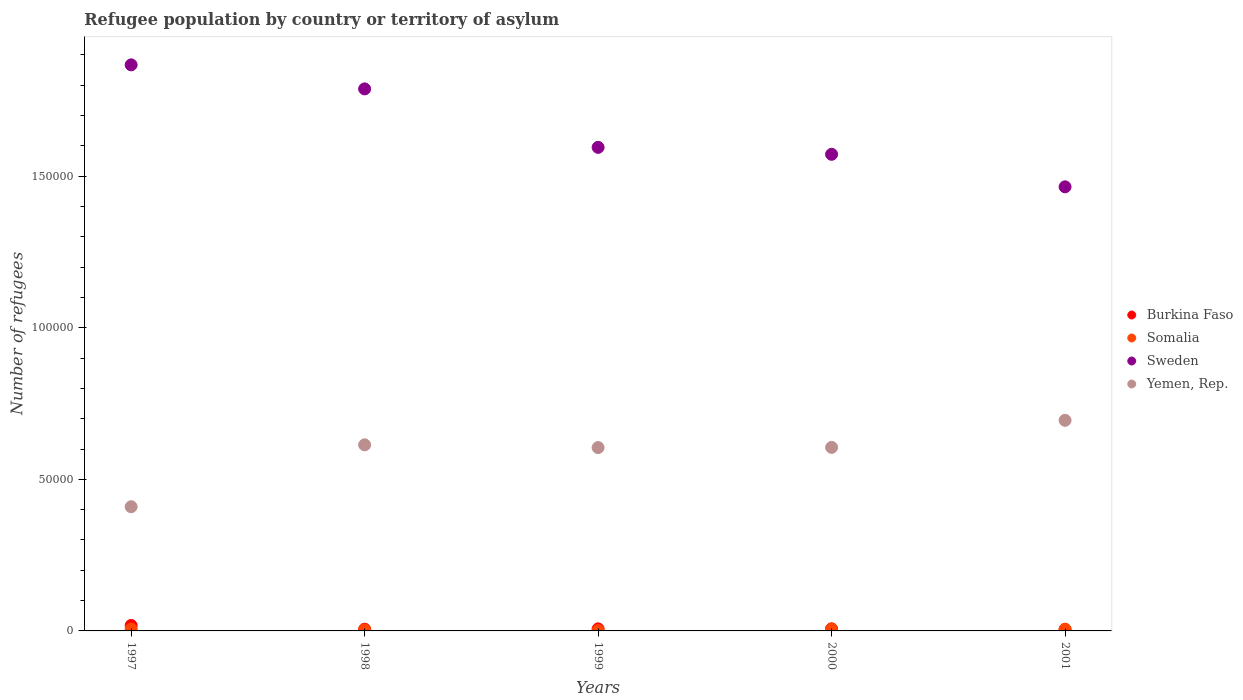How many different coloured dotlines are there?
Make the answer very short. 4. Is the number of dotlines equal to the number of legend labels?
Make the answer very short. Yes. What is the number of refugees in Burkina Faso in 1998?
Make the answer very short. 564. Across all years, what is the maximum number of refugees in Burkina Faso?
Give a very brief answer. 1801. Across all years, what is the minimum number of refugees in Somalia?
Your answer should be very brief. 130. What is the total number of refugees in Yemen, Rep. in the graph?
Offer a terse response. 2.93e+05. What is the difference between the number of refugees in Sweden in 1999 and that in 2000?
Keep it short and to the point. 2293. What is the difference between the number of refugees in Somalia in 1998 and the number of refugees in Yemen, Rep. in 2000?
Make the answer very short. -6.02e+04. What is the average number of refugees in Burkina Faso per year?
Make the answer very short. 838.6. In the year 2000, what is the difference between the number of refugees in Burkina Faso and number of refugees in Sweden?
Give a very brief answer. -1.57e+05. In how many years, is the number of refugees in Yemen, Rep. greater than 180000?
Ensure brevity in your answer.  0. What is the ratio of the number of refugees in Somalia in 1997 to that in 1999?
Make the answer very short. 4.78. What is the difference between the highest and the second highest number of refugees in Sweden?
Ensure brevity in your answer.  7930. What is the difference between the highest and the lowest number of refugees in Burkina Faso?
Your response must be concise. 1344. In how many years, is the number of refugees in Somalia greater than the average number of refugees in Somalia taken over all years?
Make the answer very short. 3. Is the sum of the number of refugees in Sweden in 1997 and 2001 greater than the maximum number of refugees in Somalia across all years?
Your answer should be compact. Yes. Does the number of refugees in Yemen, Rep. monotonically increase over the years?
Your answer should be very brief. No. Is the number of refugees in Yemen, Rep. strictly less than the number of refugees in Sweden over the years?
Give a very brief answer. Yes. How many dotlines are there?
Provide a short and direct response. 4. Are the values on the major ticks of Y-axis written in scientific E-notation?
Offer a terse response. No. Does the graph contain any zero values?
Provide a succinct answer. No. Does the graph contain grids?
Provide a succinct answer. No. How many legend labels are there?
Provide a succinct answer. 4. How are the legend labels stacked?
Provide a short and direct response. Vertical. What is the title of the graph?
Make the answer very short. Refugee population by country or territory of asylum. What is the label or title of the X-axis?
Provide a succinct answer. Years. What is the label or title of the Y-axis?
Offer a very short reply. Number of refugees. What is the Number of refugees of Burkina Faso in 1997?
Offer a very short reply. 1801. What is the Number of refugees of Somalia in 1997?
Offer a very short reply. 622. What is the Number of refugees in Sweden in 1997?
Your response must be concise. 1.87e+05. What is the Number of refugees of Yemen, Rep. in 1997?
Keep it short and to the point. 4.10e+04. What is the Number of refugees in Burkina Faso in 1998?
Keep it short and to the point. 564. What is the Number of refugees of Somalia in 1998?
Offer a terse response. 337. What is the Number of refugees in Sweden in 1998?
Offer a terse response. 1.79e+05. What is the Number of refugees of Yemen, Rep. in 1998?
Give a very brief answer. 6.14e+04. What is the Number of refugees in Burkina Faso in 1999?
Your response must be concise. 675. What is the Number of refugees in Somalia in 1999?
Give a very brief answer. 130. What is the Number of refugees of Sweden in 1999?
Your answer should be very brief. 1.60e+05. What is the Number of refugees of Yemen, Rep. in 1999?
Provide a succinct answer. 6.05e+04. What is the Number of refugees in Burkina Faso in 2000?
Offer a very short reply. 696. What is the Number of refugees in Somalia in 2000?
Offer a very short reply. 558. What is the Number of refugees of Sweden in 2000?
Offer a very short reply. 1.57e+05. What is the Number of refugees of Yemen, Rep. in 2000?
Make the answer very short. 6.05e+04. What is the Number of refugees of Burkina Faso in 2001?
Your answer should be very brief. 457. What is the Number of refugees in Somalia in 2001?
Your response must be concise. 589. What is the Number of refugees of Sweden in 2001?
Offer a terse response. 1.46e+05. What is the Number of refugees in Yemen, Rep. in 2001?
Provide a short and direct response. 6.95e+04. Across all years, what is the maximum Number of refugees in Burkina Faso?
Offer a terse response. 1801. Across all years, what is the maximum Number of refugees of Somalia?
Make the answer very short. 622. Across all years, what is the maximum Number of refugees of Sweden?
Provide a succinct answer. 1.87e+05. Across all years, what is the maximum Number of refugees in Yemen, Rep.?
Your answer should be very brief. 6.95e+04. Across all years, what is the minimum Number of refugees in Burkina Faso?
Your answer should be very brief. 457. Across all years, what is the minimum Number of refugees in Somalia?
Offer a very short reply. 130. Across all years, what is the minimum Number of refugees of Sweden?
Keep it short and to the point. 1.46e+05. Across all years, what is the minimum Number of refugees of Yemen, Rep.?
Provide a succinct answer. 4.10e+04. What is the total Number of refugees of Burkina Faso in the graph?
Your answer should be compact. 4193. What is the total Number of refugees in Somalia in the graph?
Ensure brevity in your answer.  2236. What is the total Number of refugees of Sweden in the graph?
Your response must be concise. 8.29e+05. What is the total Number of refugees of Yemen, Rep. in the graph?
Give a very brief answer. 2.93e+05. What is the difference between the Number of refugees in Burkina Faso in 1997 and that in 1998?
Ensure brevity in your answer.  1237. What is the difference between the Number of refugees in Somalia in 1997 and that in 1998?
Your answer should be compact. 285. What is the difference between the Number of refugees in Sweden in 1997 and that in 1998?
Make the answer very short. 7930. What is the difference between the Number of refugees of Yemen, Rep. in 1997 and that in 1998?
Make the answer very short. -2.04e+04. What is the difference between the Number of refugees in Burkina Faso in 1997 and that in 1999?
Make the answer very short. 1126. What is the difference between the Number of refugees of Somalia in 1997 and that in 1999?
Offer a terse response. 492. What is the difference between the Number of refugees of Sweden in 1997 and that in 1999?
Your response must be concise. 2.72e+04. What is the difference between the Number of refugees of Yemen, Rep. in 1997 and that in 1999?
Offer a terse response. -1.95e+04. What is the difference between the Number of refugees in Burkina Faso in 1997 and that in 2000?
Your response must be concise. 1105. What is the difference between the Number of refugees of Sweden in 1997 and that in 2000?
Provide a succinct answer. 2.95e+04. What is the difference between the Number of refugees in Yemen, Rep. in 1997 and that in 2000?
Keep it short and to the point. -1.96e+04. What is the difference between the Number of refugees in Burkina Faso in 1997 and that in 2001?
Offer a very short reply. 1344. What is the difference between the Number of refugees of Sweden in 1997 and that in 2001?
Ensure brevity in your answer.  4.02e+04. What is the difference between the Number of refugees of Yemen, Rep. in 1997 and that in 2001?
Give a very brief answer. -2.85e+04. What is the difference between the Number of refugees of Burkina Faso in 1998 and that in 1999?
Your answer should be compact. -111. What is the difference between the Number of refugees in Somalia in 1998 and that in 1999?
Your answer should be very brief. 207. What is the difference between the Number of refugees of Sweden in 1998 and that in 1999?
Offer a very short reply. 1.93e+04. What is the difference between the Number of refugees in Yemen, Rep. in 1998 and that in 1999?
Make the answer very short. 905. What is the difference between the Number of refugees of Burkina Faso in 1998 and that in 2000?
Offer a very short reply. -132. What is the difference between the Number of refugees in Somalia in 1998 and that in 2000?
Your response must be concise. -221. What is the difference between the Number of refugees in Sweden in 1998 and that in 2000?
Make the answer very short. 2.16e+04. What is the difference between the Number of refugees of Yemen, Rep. in 1998 and that in 2000?
Ensure brevity in your answer.  837. What is the difference between the Number of refugees of Burkina Faso in 1998 and that in 2001?
Ensure brevity in your answer.  107. What is the difference between the Number of refugees of Somalia in 1998 and that in 2001?
Your answer should be very brief. -252. What is the difference between the Number of refugees in Sweden in 1998 and that in 2001?
Offer a very short reply. 3.23e+04. What is the difference between the Number of refugees of Yemen, Rep. in 1998 and that in 2001?
Ensure brevity in your answer.  -8086. What is the difference between the Number of refugees in Burkina Faso in 1999 and that in 2000?
Ensure brevity in your answer.  -21. What is the difference between the Number of refugees in Somalia in 1999 and that in 2000?
Provide a succinct answer. -428. What is the difference between the Number of refugees in Sweden in 1999 and that in 2000?
Give a very brief answer. 2293. What is the difference between the Number of refugees in Yemen, Rep. in 1999 and that in 2000?
Ensure brevity in your answer.  -68. What is the difference between the Number of refugees of Burkina Faso in 1999 and that in 2001?
Ensure brevity in your answer.  218. What is the difference between the Number of refugees in Somalia in 1999 and that in 2001?
Your answer should be compact. -459. What is the difference between the Number of refugees of Sweden in 1999 and that in 2001?
Your response must be concise. 1.30e+04. What is the difference between the Number of refugees of Yemen, Rep. in 1999 and that in 2001?
Make the answer very short. -8991. What is the difference between the Number of refugees of Burkina Faso in 2000 and that in 2001?
Provide a short and direct response. 239. What is the difference between the Number of refugees of Somalia in 2000 and that in 2001?
Offer a terse response. -31. What is the difference between the Number of refugees in Sweden in 2000 and that in 2001?
Offer a terse response. 1.07e+04. What is the difference between the Number of refugees of Yemen, Rep. in 2000 and that in 2001?
Provide a succinct answer. -8923. What is the difference between the Number of refugees in Burkina Faso in 1997 and the Number of refugees in Somalia in 1998?
Provide a succinct answer. 1464. What is the difference between the Number of refugees of Burkina Faso in 1997 and the Number of refugees of Sweden in 1998?
Provide a short and direct response. -1.77e+05. What is the difference between the Number of refugees in Burkina Faso in 1997 and the Number of refugees in Yemen, Rep. in 1998?
Provide a short and direct response. -5.96e+04. What is the difference between the Number of refugees of Somalia in 1997 and the Number of refugees of Sweden in 1998?
Give a very brief answer. -1.78e+05. What is the difference between the Number of refugees of Somalia in 1997 and the Number of refugees of Yemen, Rep. in 1998?
Make the answer very short. -6.08e+04. What is the difference between the Number of refugees in Sweden in 1997 and the Number of refugees in Yemen, Rep. in 1998?
Ensure brevity in your answer.  1.25e+05. What is the difference between the Number of refugees in Burkina Faso in 1997 and the Number of refugees in Somalia in 1999?
Give a very brief answer. 1671. What is the difference between the Number of refugees in Burkina Faso in 1997 and the Number of refugees in Sweden in 1999?
Your answer should be compact. -1.58e+05. What is the difference between the Number of refugees of Burkina Faso in 1997 and the Number of refugees of Yemen, Rep. in 1999?
Provide a succinct answer. -5.87e+04. What is the difference between the Number of refugees of Somalia in 1997 and the Number of refugees of Sweden in 1999?
Keep it short and to the point. -1.59e+05. What is the difference between the Number of refugees in Somalia in 1997 and the Number of refugees in Yemen, Rep. in 1999?
Your answer should be compact. -5.99e+04. What is the difference between the Number of refugees in Sweden in 1997 and the Number of refugees in Yemen, Rep. in 1999?
Offer a terse response. 1.26e+05. What is the difference between the Number of refugees in Burkina Faso in 1997 and the Number of refugees in Somalia in 2000?
Your answer should be compact. 1243. What is the difference between the Number of refugees of Burkina Faso in 1997 and the Number of refugees of Sweden in 2000?
Your answer should be compact. -1.55e+05. What is the difference between the Number of refugees of Burkina Faso in 1997 and the Number of refugees of Yemen, Rep. in 2000?
Offer a very short reply. -5.87e+04. What is the difference between the Number of refugees in Somalia in 1997 and the Number of refugees in Sweden in 2000?
Provide a short and direct response. -1.57e+05. What is the difference between the Number of refugees of Somalia in 1997 and the Number of refugees of Yemen, Rep. in 2000?
Offer a terse response. -5.99e+04. What is the difference between the Number of refugees of Sweden in 1997 and the Number of refugees of Yemen, Rep. in 2000?
Offer a terse response. 1.26e+05. What is the difference between the Number of refugees of Burkina Faso in 1997 and the Number of refugees of Somalia in 2001?
Provide a succinct answer. 1212. What is the difference between the Number of refugees of Burkina Faso in 1997 and the Number of refugees of Sweden in 2001?
Provide a succinct answer. -1.45e+05. What is the difference between the Number of refugees in Burkina Faso in 1997 and the Number of refugees in Yemen, Rep. in 2001?
Make the answer very short. -6.77e+04. What is the difference between the Number of refugees in Somalia in 1997 and the Number of refugees in Sweden in 2001?
Your response must be concise. -1.46e+05. What is the difference between the Number of refugees in Somalia in 1997 and the Number of refugees in Yemen, Rep. in 2001?
Make the answer very short. -6.88e+04. What is the difference between the Number of refugees in Sweden in 1997 and the Number of refugees in Yemen, Rep. in 2001?
Provide a short and direct response. 1.17e+05. What is the difference between the Number of refugees in Burkina Faso in 1998 and the Number of refugees in Somalia in 1999?
Ensure brevity in your answer.  434. What is the difference between the Number of refugees of Burkina Faso in 1998 and the Number of refugees of Sweden in 1999?
Your answer should be very brief. -1.59e+05. What is the difference between the Number of refugees of Burkina Faso in 1998 and the Number of refugees of Yemen, Rep. in 1999?
Provide a short and direct response. -5.99e+04. What is the difference between the Number of refugees of Somalia in 1998 and the Number of refugees of Sweden in 1999?
Make the answer very short. -1.59e+05. What is the difference between the Number of refugees in Somalia in 1998 and the Number of refugees in Yemen, Rep. in 1999?
Give a very brief answer. -6.01e+04. What is the difference between the Number of refugees of Sweden in 1998 and the Number of refugees of Yemen, Rep. in 1999?
Your answer should be compact. 1.18e+05. What is the difference between the Number of refugees of Burkina Faso in 1998 and the Number of refugees of Somalia in 2000?
Provide a short and direct response. 6. What is the difference between the Number of refugees in Burkina Faso in 1998 and the Number of refugees in Sweden in 2000?
Make the answer very short. -1.57e+05. What is the difference between the Number of refugees in Burkina Faso in 1998 and the Number of refugees in Yemen, Rep. in 2000?
Provide a succinct answer. -6.00e+04. What is the difference between the Number of refugees of Somalia in 1998 and the Number of refugees of Sweden in 2000?
Ensure brevity in your answer.  -1.57e+05. What is the difference between the Number of refugees in Somalia in 1998 and the Number of refugees in Yemen, Rep. in 2000?
Your answer should be compact. -6.02e+04. What is the difference between the Number of refugees of Sweden in 1998 and the Number of refugees of Yemen, Rep. in 2000?
Your answer should be compact. 1.18e+05. What is the difference between the Number of refugees in Burkina Faso in 1998 and the Number of refugees in Sweden in 2001?
Your answer should be very brief. -1.46e+05. What is the difference between the Number of refugees of Burkina Faso in 1998 and the Number of refugees of Yemen, Rep. in 2001?
Ensure brevity in your answer.  -6.89e+04. What is the difference between the Number of refugees of Somalia in 1998 and the Number of refugees of Sweden in 2001?
Your answer should be compact. -1.46e+05. What is the difference between the Number of refugees of Somalia in 1998 and the Number of refugees of Yemen, Rep. in 2001?
Offer a terse response. -6.91e+04. What is the difference between the Number of refugees of Sweden in 1998 and the Number of refugees of Yemen, Rep. in 2001?
Your response must be concise. 1.09e+05. What is the difference between the Number of refugees in Burkina Faso in 1999 and the Number of refugees in Somalia in 2000?
Provide a short and direct response. 117. What is the difference between the Number of refugees of Burkina Faso in 1999 and the Number of refugees of Sweden in 2000?
Offer a terse response. -1.57e+05. What is the difference between the Number of refugees of Burkina Faso in 1999 and the Number of refugees of Yemen, Rep. in 2000?
Your response must be concise. -5.99e+04. What is the difference between the Number of refugees in Somalia in 1999 and the Number of refugees in Sweden in 2000?
Your answer should be very brief. -1.57e+05. What is the difference between the Number of refugees of Somalia in 1999 and the Number of refugees of Yemen, Rep. in 2000?
Offer a very short reply. -6.04e+04. What is the difference between the Number of refugees of Sweden in 1999 and the Number of refugees of Yemen, Rep. in 2000?
Provide a succinct answer. 9.90e+04. What is the difference between the Number of refugees in Burkina Faso in 1999 and the Number of refugees in Sweden in 2001?
Offer a terse response. -1.46e+05. What is the difference between the Number of refugees of Burkina Faso in 1999 and the Number of refugees of Yemen, Rep. in 2001?
Provide a short and direct response. -6.88e+04. What is the difference between the Number of refugees in Somalia in 1999 and the Number of refugees in Sweden in 2001?
Your answer should be compact. -1.46e+05. What is the difference between the Number of refugees in Somalia in 1999 and the Number of refugees in Yemen, Rep. in 2001?
Give a very brief answer. -6.93e+04. What is the difference between the Number of refugees of Sweden in 1999 and the Number of refugees of Yemen, Rep. in 2001?
Make the answer very short. 9.00e+04. What is the difference between the Number of refugees in Burkina Faso in 2000 and the Number of refugees in Somalia in 2001?
Give a very brief answer. 107. What is the difference between the Number of refugees of Burkina Faso in 2000 and the Number of refugees of Sweden in 2001?
Provide a succinct answer. -1.46e+05. What is the difference between the Number of refugees of Burkina Faso in 2000 and the Number of refugees of Yemen, Rep. in 2001?
Make the answer very short. -6.88e+04. What is the difference between the Number of refugees in Somalia in 2000 and the Number of refugees in Sweden in 2001?
Provide a succinct answer. -1.46e+05. What is the difference between the Number of refugees of Somalia in 2000 and the Number of refugees of Yemen, Rep. in 2001?
Keep it short and to the point. -6.89e+04. What is the difference between the Number of refugees in Sweden in 2000 and the Number of refugees in Yemen, Rep. in 2001?
Give a very brief answer. 8.78e+04. What is the average Number of refugees of Burkina Faso per year?
Make the answer very short. 838.6. What is the average Number of refugees in Somalia per year?
Your response must be concise. 447.2. What is the average Number of refugees in Sweden per year?
Offer a very short reply. 1.66e+05. What is the average Number of refugees in Yemen, Rep. per year?
Provide a succinct answer. 5.86e+04. In the year 1997, what is the difference between the Number of refugees in Burkina Faso and Number of refugees in Somalia?
Give a very brief answer. 1179. In the year 1997, what is the difference between the Number of refugees in Burkina Faso and Number of refugees in Sweden?
Keep it short and to the point. -1.85e+05. In the year 1997, what is the difference between the Number of refugees of Burkina Faso and Number of refugees of Yemen, Rep.?
Give a very brief answer. -3.92e+04. In the year 1997, what is the difference between the Number of refugees of Somalia and Number of refugees of Sweden?
Make the answer very short. -1.86e+05. In the year 1997, what is the difference between the Number of refugees in Somalia and Number of refugees in Yemen, Rep.?
Offer a very short reply. -4.03e+04. In the year 1997, what is the difference between the Number of refugees in Sweden and Number of refugees in Yemen, Rep.?
Provide a short and direct response. 1.46e+05. In the year 1998, what is the difference between the Number of refugees of Burkina Faso and Number of refugees of Somalia?
Offer a very short reply. 227. In the year 1998, what is the difference between the Number of refugees of Burkina Faso and Number of refugees of Sweden?
Your answer should be very brief. -1.78e+05. In the year 1998, what is the difference between the Number of refugees in Burkina Faso and Number of refugees in Yemen, Rep.?
Provide a short and direct response. -6.08e+04. In the year 1998, what is the difference between the Number of refugees in Somalia and Number of refugees in Sweden?
Your response must be concise. -1.78e+05. In the year 1998, what is the difference between the Number of refugees in Somalia and Number of refugees in Yemen, Rep.?
Provide a short and direct response. -6.10e+04. In the year 1998, what is the difference between the Number of refugees in Sweden and Number of refugees in Yemen, Rep.?
Ensure brevity in your answer.  1.17e+05. In the year 1999, what is the difference between the Number of refugees in Burkina Faso and Number of refugees in Somalia?
Keep it short and to the point. 545. In the year 1999, what is the difference between the Number of refugees of Burkina Faso and Number of refugees of Sweden?
Offer a very short reply. -1.59e+05. In the year 1999, what is the difference between the Number of refugees in Burkina Faso and Number of refugees in Yemen, Rep.?
Ensure brevity in your answer.  -5.98e+04. In the year 1999, what is the difference between the Number of refugees in Somalia and Number of refugees in Sweden?
Your answer should be very brief. -1.59e+05. In the year 1999, what is the difference between the Number of refugees of Somalia and Number of refugees of Yemen, Rep.?
Ensure brevity in your answer.  -6.03e+04. In the year 1999, what is the difference between the Number of refugees in Sweden and Number of refugees in Yemen, Rep.?
Your answer should be very brief. 9.90e+04. In the year 2000, what is the difference between the Number of refugees in Burkina Faso and Number of refugees in Somalia?
Make the answer very short. 138. In the year 2000, what is the difference between the Number of refugees in Burkina Faso and Number of refugees in Sweden?
Offer a very short reply. -1.57e+05. In the year 2000, what is the difference between the Number of refugees of Burkina Faso and Number of refugees of Yemen, Rep.?
Keep it short and to the point. -5.98e+04. In the year 2000, what is the difference between the Number of refugees of Somalia and Number of refugees of Sweden?
Your answer should be very brief. -1.57e+05. In the year 2000, what is the difference between the Number of refugees of Somalia and Number of refugees of Yemen, Rep.?
Keep it short and to the point. -6.00e+04. In the year 2000, what is the difference between the Number of refugees in Sweden and Number of refugees in Yemen, Rep.?
Provide a succinct answer. 9.67e+04. In the year 2001, what is the difference between the Number of refugees of Burkina Faso and Number of refugees of Somalia?
Ensure brevity in your answer.  -132. In the year 2001, what is the difference between the Number of refugees of Burkina Faso and Number of refugees of Sweden?
Give a very brief answer. -1.46e+05. In the year 2001, what is the difference between the Number of refugees of Burkina Faso and Number of refugees of Yemen, Rep.?
Your response must be concise. -6.90e+04. In the year 2001, what is the difference between the Number of refugees of Somalia and Number of refugees of Sweden?
Your response must be concise. -1.46e+05. In the year 2001, what is the difference between the Number of refugees in Somalia and Number of refugees in Yemen, Rep.?
Ensure brevity in your answer.  -6.89e+04. In the year 2001, what is the difference between the Number of refugees in Sweden and Number of refugees in Yemen, Rep.?
Offer a terse response. 7.70e+04. What is the ratio of the Number of refugees in Burkina Faso in 1997 to that in 1998?
Keep it short and to the point. 3.19. What is the ratio of the Number of refugees of Somalia in 1997 to that in 1998?
Your response must be concise. 1.85. What is the ratio of the Number of refugees in Sweden in 1997 to that in 1998?
Offer a terse response. 1.04. What is the ratio of the Number of refugees of Yemen, Rep. in 1997 to that in 1998?
Keep it short and to the point. 0.67. What is the ratio of the Number of refugees in Burkina Faso in 1997 to that in 1999?
Your answer should be very brief. 2.67. What is the ratio of the Number of refugees in Somalia in 1997 to that in 1999?
Your response must be concise. 4.78. What is the ratio of the Number of refugees of Sweden in 1997 to that in 1999?
Your answer should be very brief. 1.17. What is the ratio of the Number of refugees of Yemen, Rep. in 1997 to that in 1999?
Give a very brief answer. 0.68. What is the ratio of the Number of refugees in Burkina Faso in 1997 to that in 2000?
Your answer should be very brief. 2.59. What is the ratio of the Number of refugees in Somalia in 1997 to that in 2000?
Your response must be concise. 1.11. What is the ratio of the Number of refugees of Sweden in 1997 to that in 2000?
Ensure brevity in your answer.  1.19. What is the ratio of the Number of refugees in Yemen, Rep. in 1997 to that in 2000?
Your answer should be compact. 0.68. What is the ratio of the Number of refugees in Burkina Faso in 1997 to that in 2001?
Your response must be concise. 3.94. What is the ratio of the Number of refugees in Somalia in 1997 to that in 2001?
Keep it short and to the point. 1.06. What is the ratio of the Number of refugees in Sweden in 1997 to that in 2001?
Give a very brief answer. 1.27. What is the ratio of the Number of refugees of Yemen, Rep. in 1997 to that in 2001?
Offer a terse response. 0.59. What is the ratio of the Number of refugees of Burkina Faso in 1998 to that in 1999?
Offer a very short reply. 0.84. What is the ratio of the Number of refugees in Somalia in 1998 to that in 1999?
Your response must be concise. 2.59. What is the ratio of the Number of refugees in Sweden in 1998 to that in 1999?
Provide a succinct answer. 1.12. What is the ratio of the Number of refugees in Burkina Faso in 1998 to that in 2000?
Make the answer very short. 0.81. What is the ratio of the Number of refugees of Somalia in 1998 to that in 2000?
Your answer should be very brief. 0.6. What is the ratio of the Number of refugees of Sweden in 1998 to that in 2000?
Keep it short and to the point. 1.14. What is the ratio of the Number of refugees in Yemen, Rep. in 1998 to that in 2000?
Ensure brevity in your answer.  1.01. What is the ratio of the Number of refugees in Burkina Faso in 1998 to that in 2001?
Ensure brevity in your answer.  1.23. What is the ratio of the Number of refugees of Somalia in 1998 to that in 2001?
Provide a short and direct response. 0.57. What is the ratio of the Number of refugees of Sweden in 1998 to that in 2001?
Make the answer very short. 1.22. What is the ratio of the Number of refugees of Yemen, Rep. in 1998 to that in 2001?
Offer a terse response. 0.88. What is the ratio of the Number of refugees of Burkina Faso in 1999 to that in 2000?
Your answer should be very brief. 0.97. What is the ratio of the Number of refugees of Somalia in 1999 to that in 2000?
Your answer should be compact. 0.23. What is the ratio of the Number of refugees in Sweden in 1999 to that in 2000?
Your response must be concise. 1.01. What is the ratio of the Number of refugees of Yemen, Rep. in 1999 to that in 2000?
Your response must be concise. 1. What is the ratio of the Number of refugees in Burkina Faso in 1999 to that in 2001?
Offer a terse response. 1.48. What is the ratio of the Number of refugees of Somalia in 1999 to that in 2001?
Ensure brevity in your answer.  0.22. What is the ratio of the Number of refugees in Sweden in 1999 to that in 2001?
Offer a very short reply. 1.09. What is the ratio of the Number of refugees of Yemen, Rep. in 1999 to that in 2001?
Your answer should be very brief. 0.87. What is the ratio of the Number of refugees of Burkina Faso in 2000 to that in 2001?
Ensure brevity in your answer.  1.52. What is the ratio of the Number of refugees of Sweden in 2000 to that in 2001?
Your answer should be very brief. 1.07. What is the ratio of the Number of refugees in Yemen, Rep. in 2000 to that in 2001?
Offer a terse response. 0.87. What is the difference between the highest and the second highest Number of refugees in Burkina Faso?
Make the answer very short. 1105. What is the difference between the highest and the second highest Number of refugees of Sweden?
Provide a succinct answer. 7930. What is the difference between the highest and the second highest Number of refugees in Yemen, Rep.?
Offer a terse response. 8086. What is the difference between the highest and the lowest Number of refugees in Burkina Faso?
Give a very brief answer. 1344. What is the difference between the highest and the lowest Number of refugees of Somalia?
Your response must be concise. 492. What is the difference between the highest and the lowest Number of refugees of Sweden?
Offer a terse response. 4.02e+04. What is the difference between the highest and the lowest Number of refugees in Yemen, Rep.?
Offer a very short reply. 2.85e+04. 